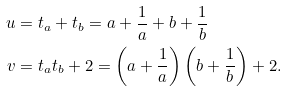<formula> <loc_0><loc_0><loc_500><loc_500>u & = t _ { a } + t _ { b } = a + \frac { 1 } { a } + b + \frac { 1 } { b } \\ v & = t _ { a } t _ { b } + 2 = \left ( a + \frac { 1 } { a } \right ) \left ( b + \frac { 1 } { b } \right ) + 2 .</formula> 